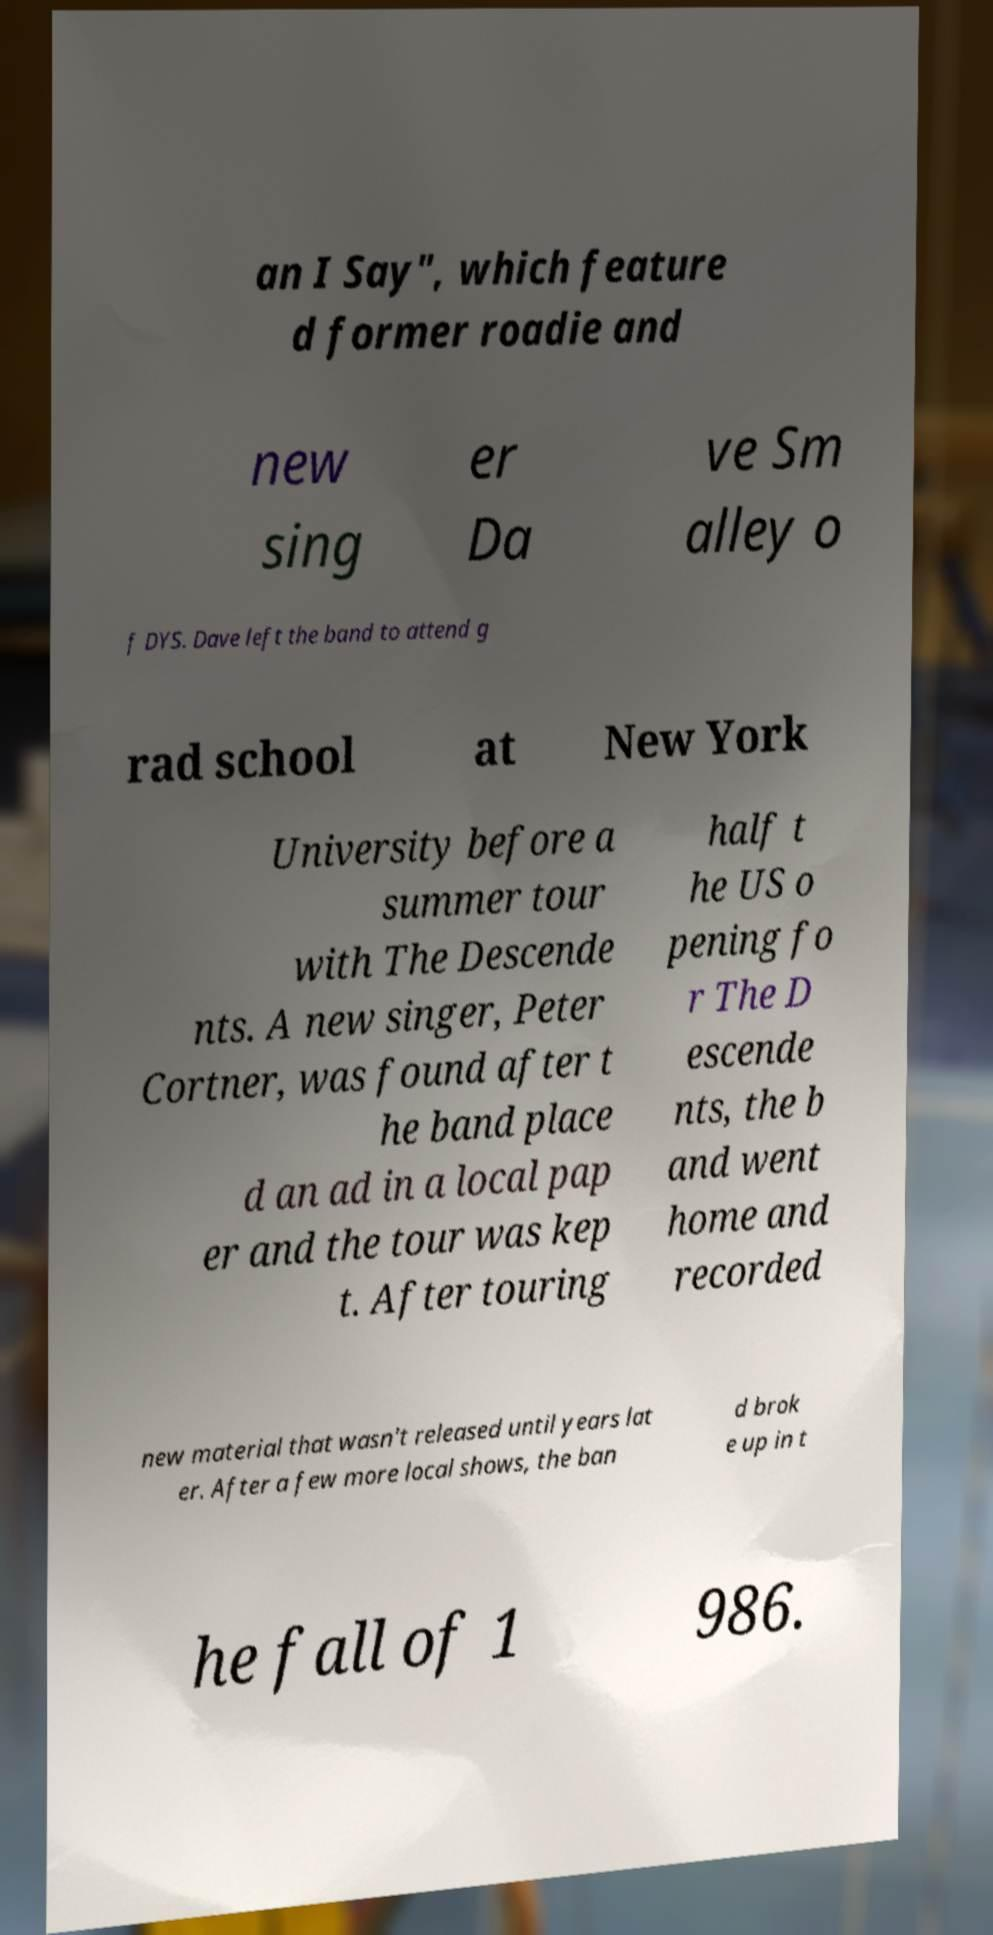Could you assist in decoding the text presented in this image and type it out clearly? an I Say", which feature d former roadie and new sing er Da ve Sm alley o f DYS. Dave left the band to attend g rad school at New York University before a summer tour with The Descende nts. A new singer, Peter Cortner, was found after t he band place d an ad in a local pap er and the tour was kep t. After touring half t he US o pening fo r The D escende nts, the b and went home and recorded new material that wasn't released until years lat er. After a few more local shows, the ban d brok e up in t he fall of 1 986. 